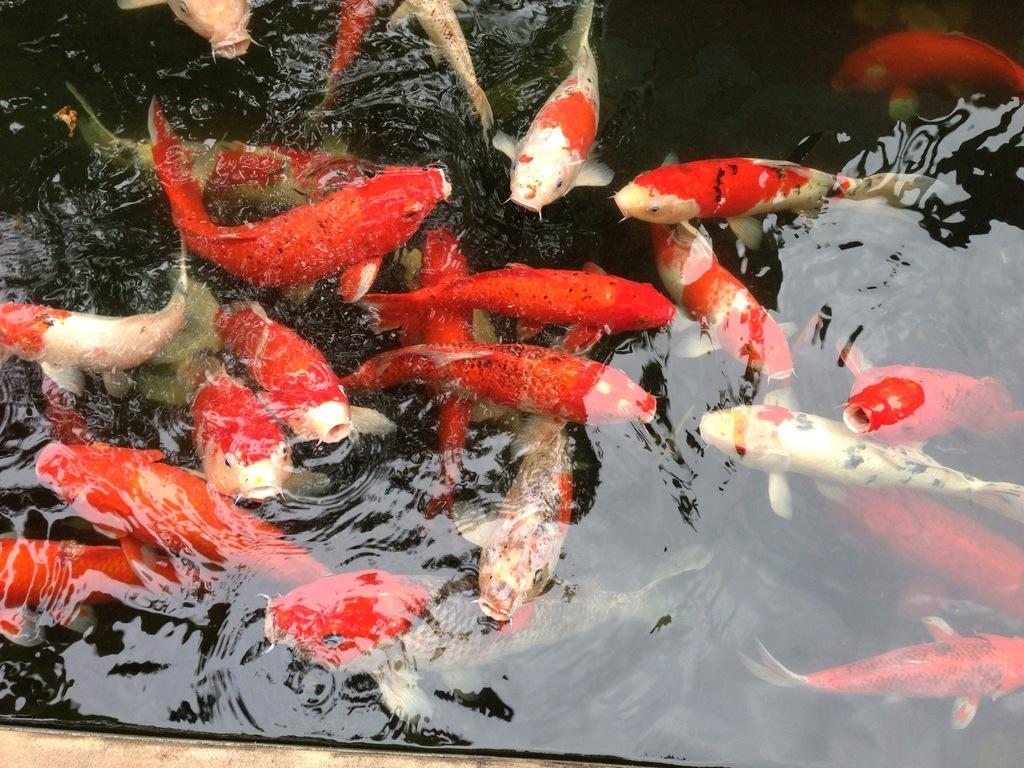What is the main subject in the center of the image? There is water in the center of the image. What can be found in the water? There are fishes in the water. Can you describe the appearance of the fishes? The fishes are red and white in color. What type of bird can be seen flying over the water in the image? There is no bird visible in the image; it only features water and fishes. 